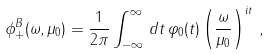<formula> <loc_0><loc_0><loc_500><loc_500>\phi _ { + } ^ { B } ( \omega , \mu _ { 0 } ) = \frac { 1 } { 2 \pi } \int _ { - \infty } ^ { \infty } \, d t \, \varphi _ { 0 } ( t ) \left ( \frac { \omega } { \mu _ { 0 } } \right ) ^ { i t } \, ,</formula> 